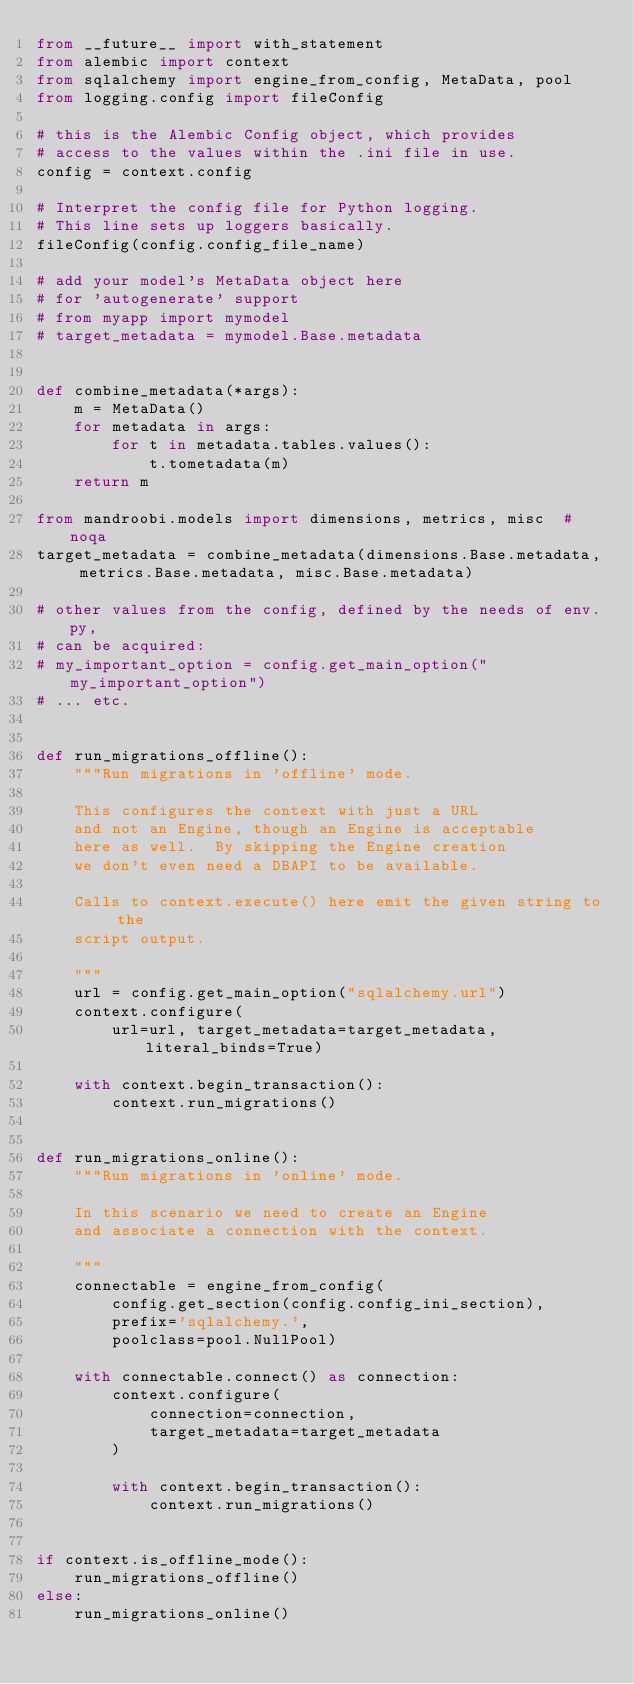<code> <loc_0><loc_0><loc_500><loc_500><_Python_>from __future__ import with_statement
from alembic import context
from sqlalchemy import engine_from_config, MetaData, pool
from logging.config import fileConfig

# this is the Alembic Config object, which provides
# access to the values within the .ini file in use.
config = context.config

# Interpret the config file for Python logging.
# This line sets up loggers basically.
fileConfig(config.config_file_name)

# add your model's MetaData object here
# for 'autogenerate' support
# from myapp import mymodel
# target_metadata = mymodel.Base.metadata


def combine_metadata(*args):
    m = MetaData()
    for metadata in args:
        for t in metadata.tables.values():
            t.tometadata(m)
    return m

from mandroobi.models import dimensions, metrics, misc  # noqa
target_metadata = combine_metadata(dimensions.Base.metadata, metrics.Base.metadata, misc.Base.metadata)

# other values from the config, defined by the needs of env.py,
# can be acquired:
# my_important_option = config.get_main_option("my_important_option")
# ... etc.


def run_migrations_offline():
    """Run migrations in 'offline' mode.

    This configures the context with just a URL
    and not an Engine, though an Engine is acceptable
    here as well.  By skipping the Engine creation
    we don't even need a DBAPI to be available.

    Calls to context.execute() here emit the given string to the
    script output.

    """
    url = config.get_main_option("sqlalchemy.url")
    context.configure(
        url=url, target_metadata=target_metadata, literal_binds=True)

    with context.begin_transaction():
        context.run_migrations()


def run_migrations_online():
    """Run migrations in 'online' mode.

    In this scenario we need to create an Engine
    and associate a connection with the context.

    """
    connectable = engine_from_config(
        config.get_section(config.config_ini_section),
        prefix='sqlalchemy.',
        poolclass=pool.NullPool)

    with connectable.connect() as connection:
        context.configure(
            connection=connection,
            target_metadata=target_metadata
        )

        with context.begin_transaction():
            context.run_migrations()


if context.is_offline_mode():
    run_migrations_offline()
else:
    run_migrations_online()
</code> 